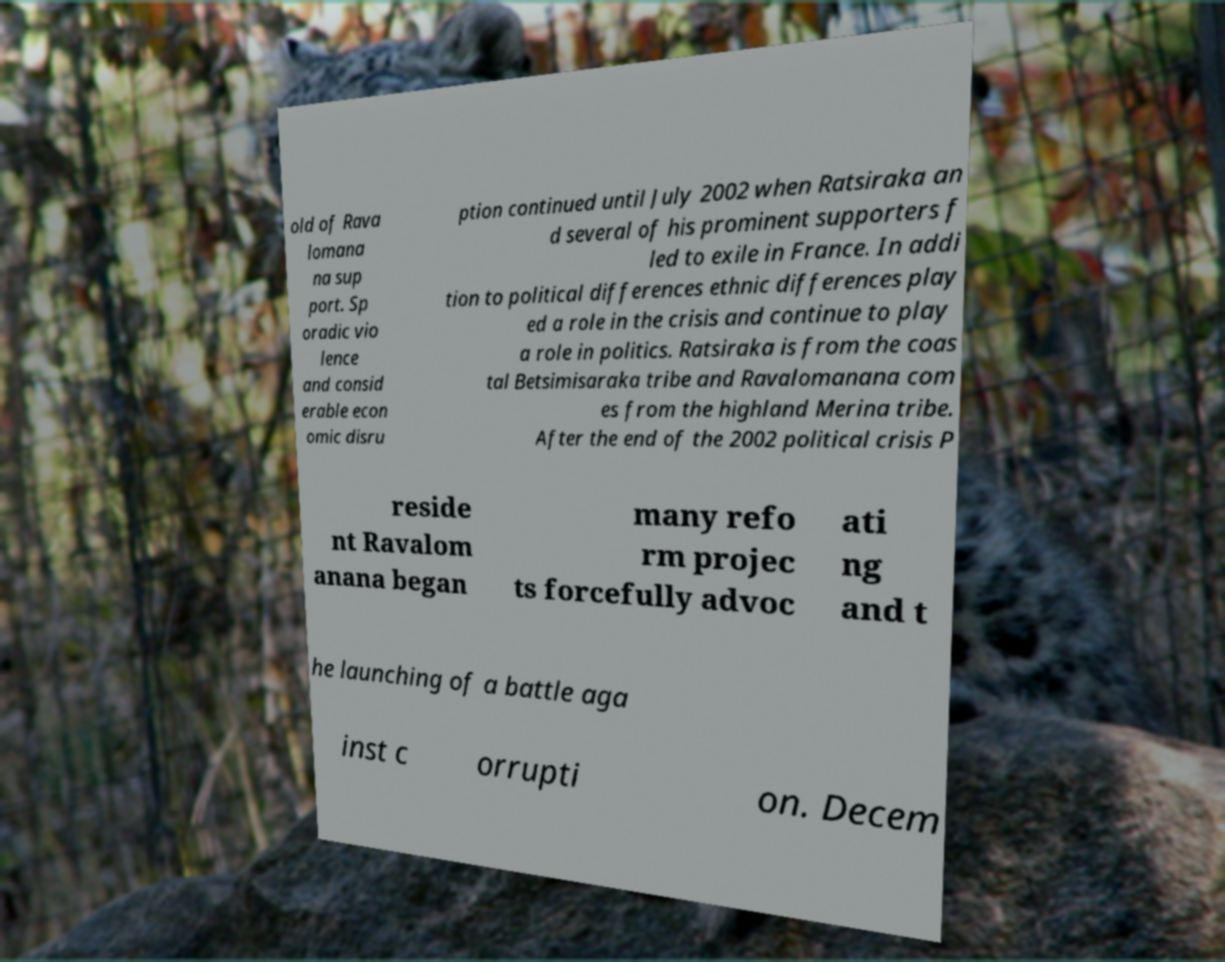Could you extract and type out the text from this image? old of Rava lomana na sup port. Sp oradic vio lence and consid erable econ omic disru ption continued until July 2002 when Ratsiraka an d several of his prominent supporters f led to exile in France. In addi tion to political differences ethnic differences play ed a role in the crisis and continue to play a role in politics. Ratsiraka is from the coas tal Betsimisaraka tribe and Ravalomanana com es from the highland Merina tribe. After the end of the 2002 political crisis P reside nt Ravalom anana began many refo rm projec ts forcefully advoc ati ng and t he launching of a battle aga inst c orrupti on. Decem 